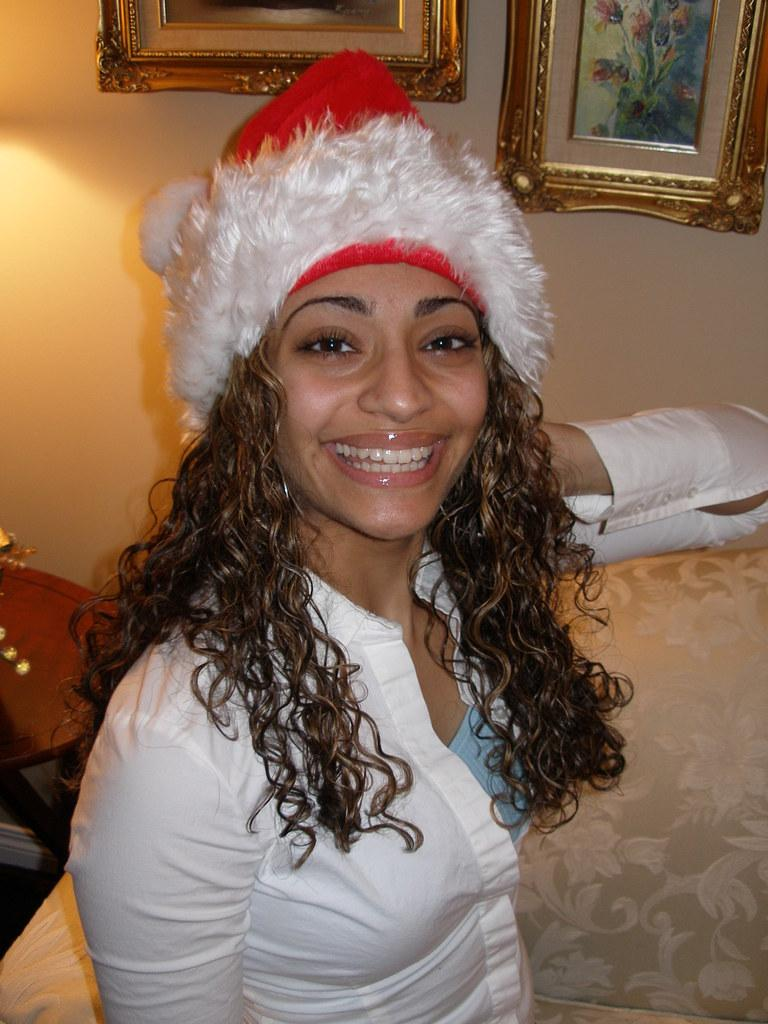What is the primary subject of the image? There is a person in the image. How is the person depicted in the image? The person is smiling. What can be seen on the wall in the image? There are photo frames on the wall in the image. What type of salt is being used to season the person's food in the image? There is no salt or food present in the image; it only features a person smiling with photo frames on the wall. 